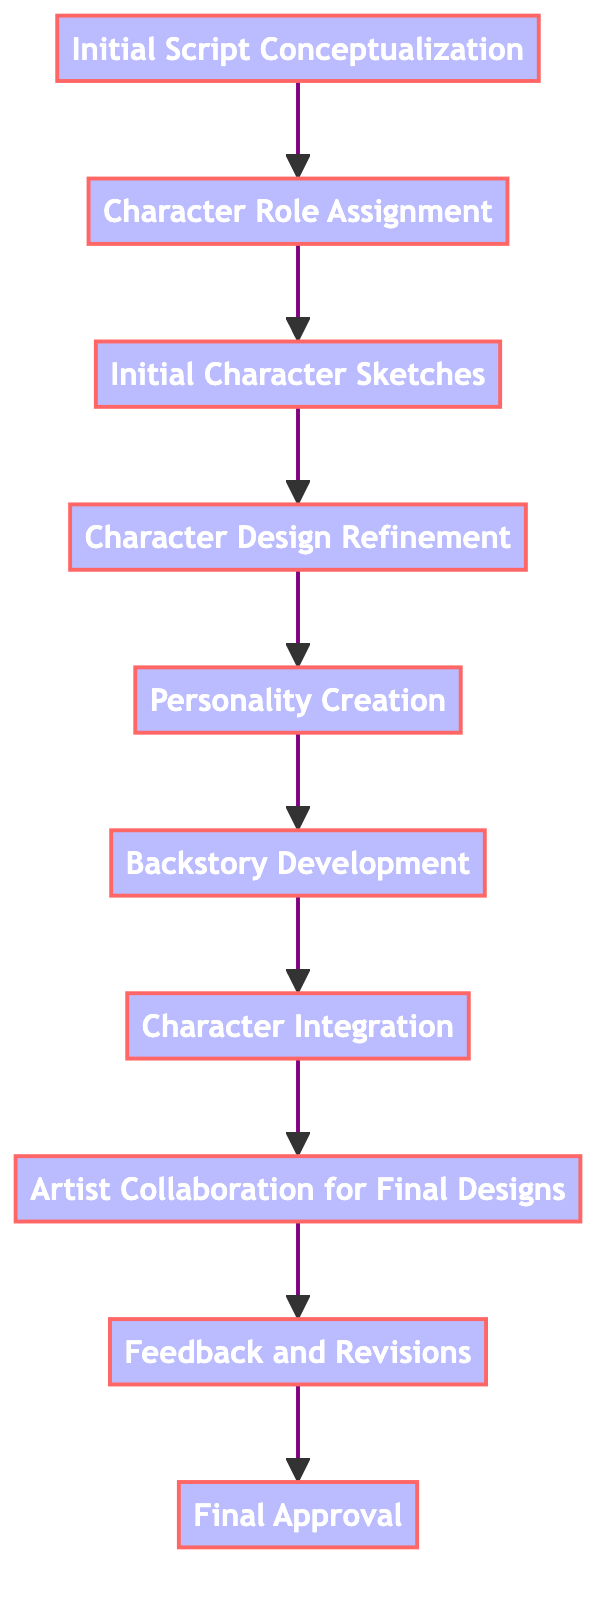What is the first step in the character development workflow? The first step in the workflow is "Initial Script Conceptualization," which establishes the foundation by brainstorming core themes, plot points, and character roles.
Answer: Initial Script Conceptualization How many steps are there in total? By counting each node in the flowchart, we find there are ten distinct steps in the character development workflow.
Answer: 10 Which step comes after "Character Role Assignment"? In the sequence of the diagram, "Initial Character Sketches" directly follows "Character Role Assignment".
Answer: Initial Character Sketches What is the last step in the workflow? The last step shown in the diagram is "Final Approval," where final decisions regarding character designs and backstories are made.
Answer: Final Approval Which two steps are primarily focused on refining character designs? The steps that focus on refining character designs are "Character Design Refinement" and "Artist Collaboration for Final Designs."
Answer: Character Design Refinement, Artist Collaboration for Final Designs What step involves developing detailed character backgrounds? The step dedicated to creating detailed character backgrounds is "Backstory Development."
Answer: Backstory Development Which two steps are directly connected to personality features? The steps that are connected to the personality features of characters are "Personality Creation" and "Backstory Development," as they both contribute to the depth of character traits and experiences.
Answer: Personality Creation, Backstory Development What is the relationship between "Feedback and Revisions" and "Final Approval"? "Feedback and Revisions" leads to "Final Approval," indicating that the team reviews and revises character designs before seeking final authorization.
Answer: Feedback and Revisions leads to Final Approval What character role is typically assigned first in the process? The "Character Role Assignment" is typically the step where roles like protagonist or antagonist are assigned, which is foundational for other development stages.
Answer: Character Role Assignment 